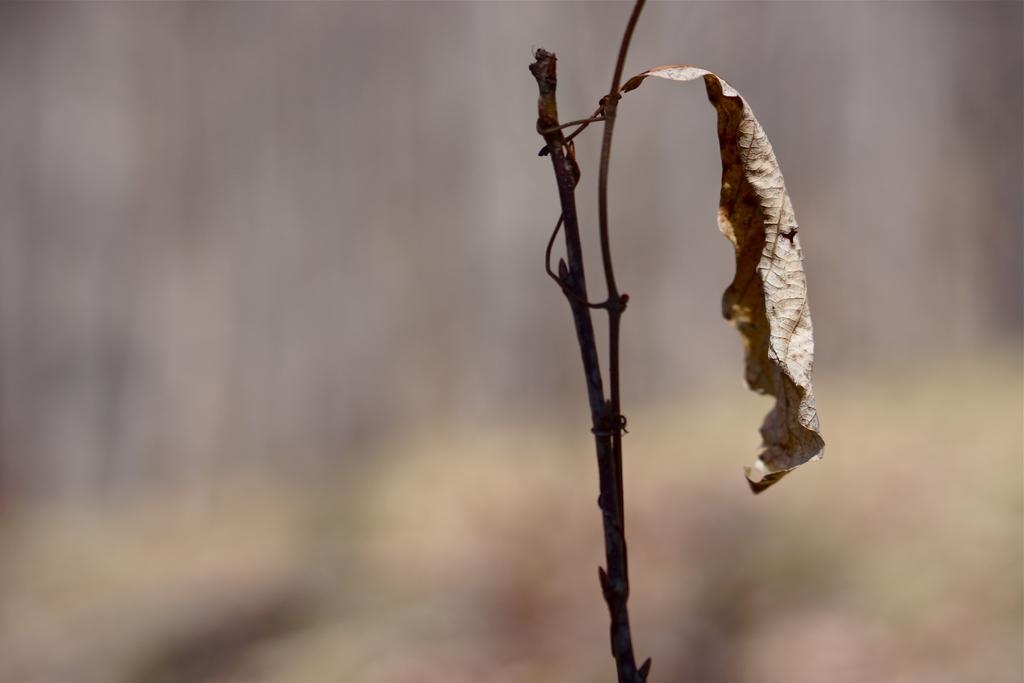What is the main subject of the image? The main subject of the image is a dry leaf with a stem. Can you describe the background of the image? The background of the image is blurry. What type of trousers can be seen in the image? There are no trousers present in the image; it features a dry leaf with a stem against a blurry background. How many clouds are visible in the image? There are no clouds visible in the image; it features a dry leaf with a stem against a blurry background. 